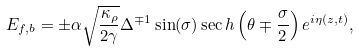Convert formula to latex. <formula><loc_0><loc_0><loc_500><loc_500>E _ { f , b } = \pm \alpha \sqrt { \frac { \kappa _ { \rho } } { 2 \gamma } } \Delta ^ { \mp 1 } \sin ( \sigma ) \sec h \left ( \theta \mp \frac { \sigma } { 2 } \right ) e ^ { i \eta ( z , t ) } ,</formula> 